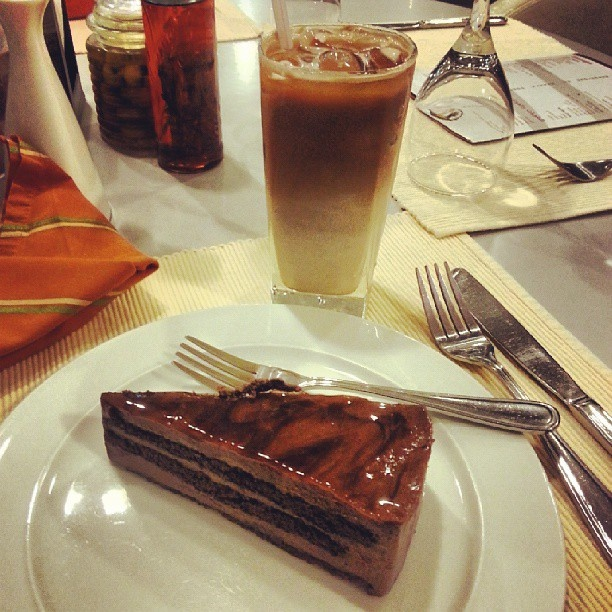Describe the objects in this image and their specific colors. I can see dining table in tan and khaki tones, cake in tan, maroon, black, and brown tones, cup in tan, maroon, brown, and gray tones, wine glass in tan tones, and cup in tan, black, maroon, and brown tones in this image. 